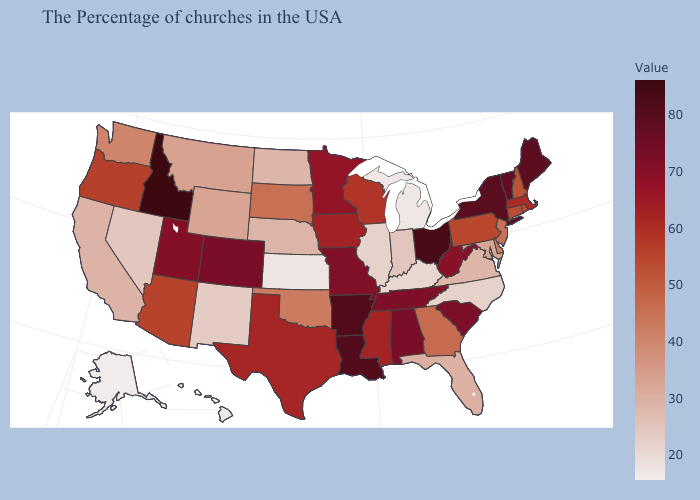Among the states that border Illinois , which have the lowest value?
Quick response, please. Kentucky. Among the states that border Michigan , which have the lowest value?
Give a very brief answer. Indiana. Which states have the lowest value in the South?
Give a very brief answer. Kentucky. 